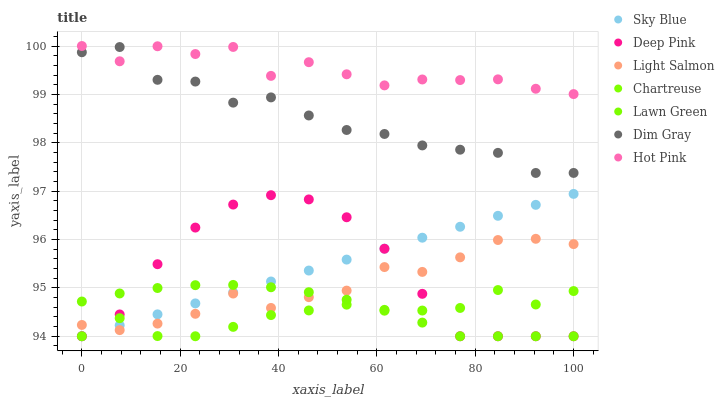Does Chartreuse have the minimum area under the curve?
Answer yes or no. Yes. Does Hot Pink have the maximum area under the curve?
Answer yes or no. Yes. Does Light Salmon have the minimum area under the curve?
Answer yes or no. No. Does Light Salmon have the maximum area under the curve?
Answer yes or no. No. Is Sky Blue the smoothest?
Answer yes or no. Yes. Is Hot Pink the roughest?
Answer yes or no. Yes. Is Light Salmon the smoothest?
Answer yes or no. No. Is Light Salmon the roughest?
Answer yes or no. No. Does Lawn Green have the lowest value?
Answer yes or no. Yes. Does Light Salmon have the lowest value?
Answer yes or no. No. Does Hot Pink have the highest value?
Answer yes or no. Yes. Does Light Salmon have the highest value?
Answer yes or no. No. Is Sky Blue less than Hot Pink?
Answer yes or no. Yes. Is Hot Pink greater than Chartreuse?
Answer yes or no. Yes. Does Sky Blue intersect Light Salmon?
Answer yes or no. Yes. Is Sky Blue less than Light Salmon?
Answer yes or no. No. Is Sky Blue greater than Light Salmon?
Answer yes or no. No. Does Sky Blue intersect Hot Pink?
Answer yes or no. No. 